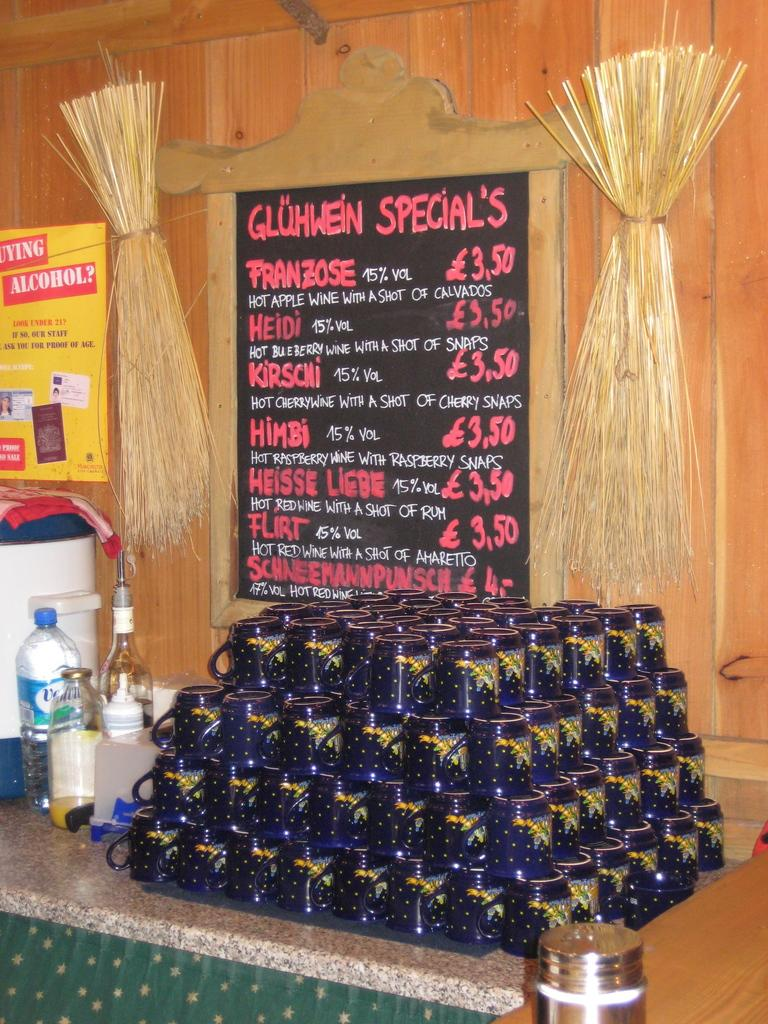<image>
Relay a brief, clear account of the picture shown. The Gluhwein Specials include Heidi and Kirschi according to this sign. 